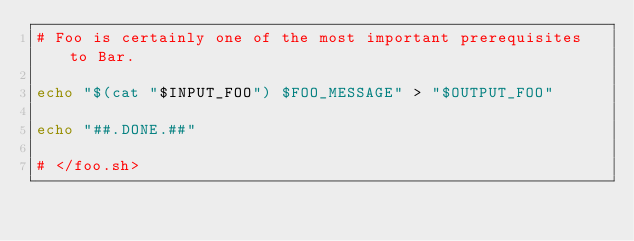<code> <loc_0><loc_0><loc_500><loc_500><_Bash_># Foo is certainly one of the most important prerequisites to Bar.

echo "$(cat "$INPUT_FOO") $FOO_MESSAGE" > "$OUTPUT_FOO"

echo "##.DONE.##"

# </foo.sh>
</code> 